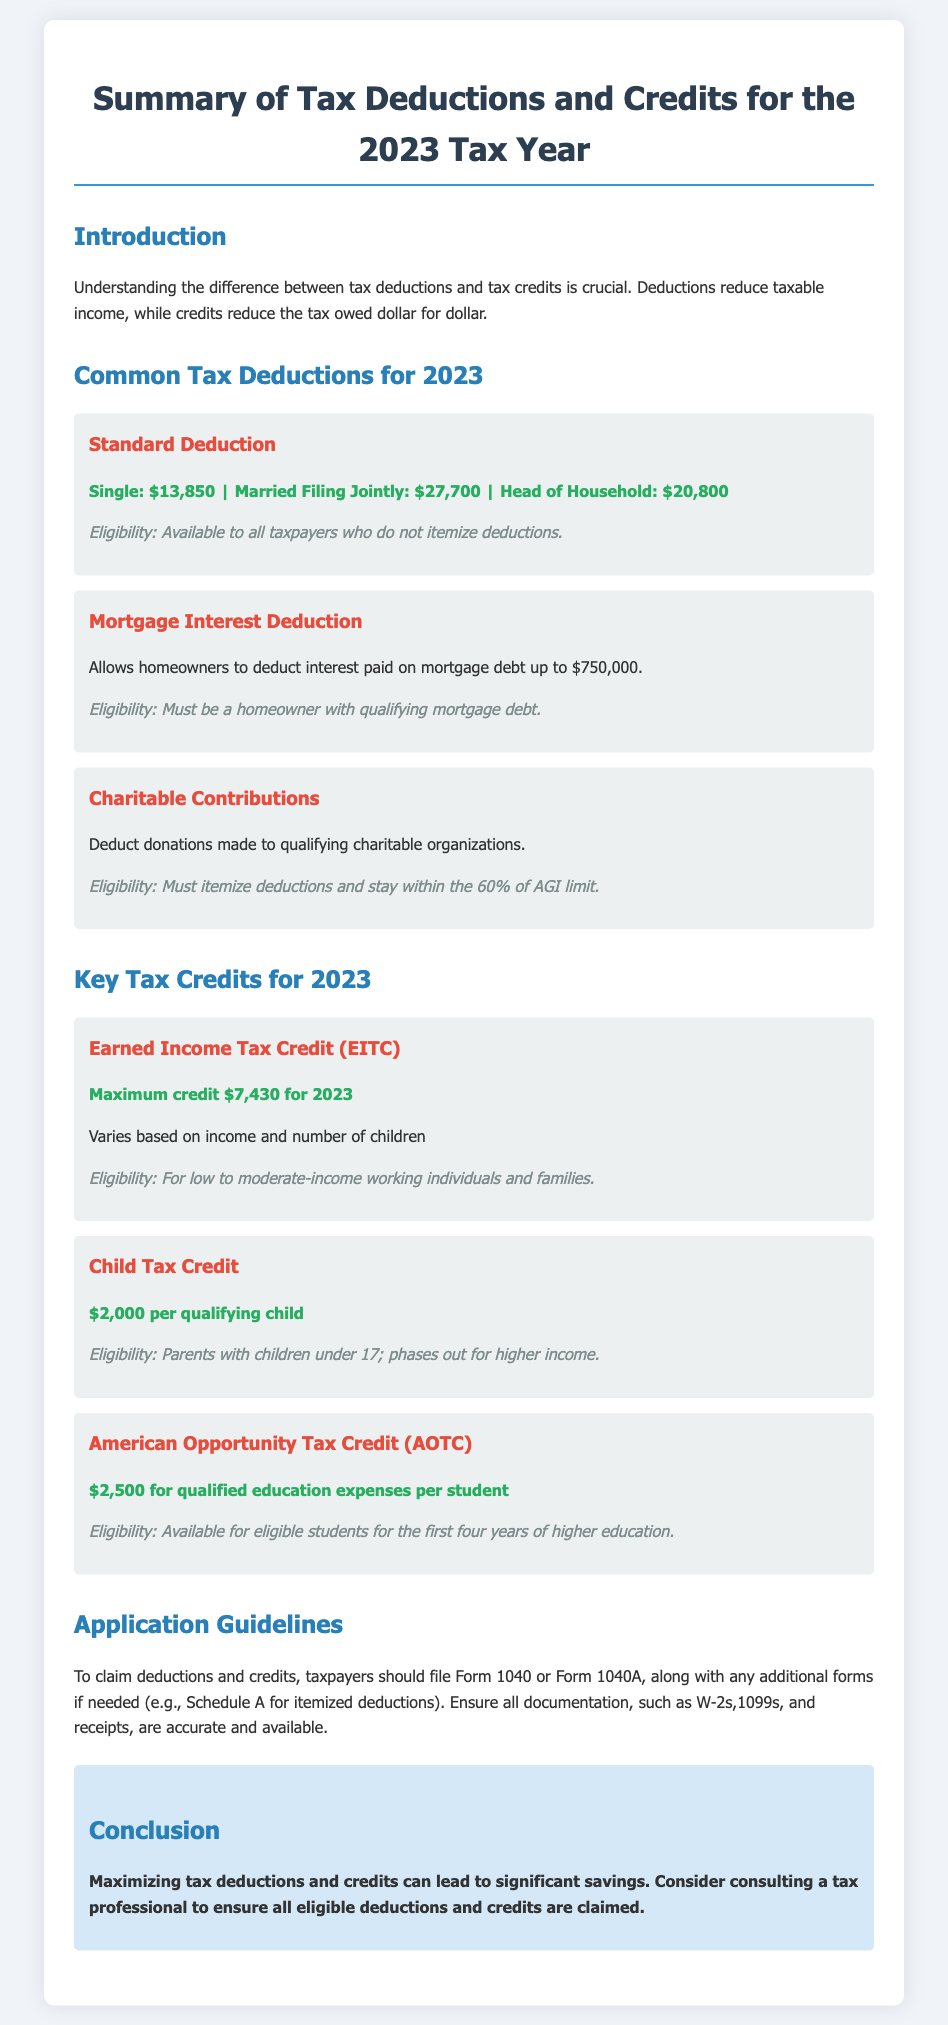What is the amount for the Single Standard Deduction? The Single Standard Deduction is specified in the document as $13,850.
Answer: $13,850 What is the maximum credit for the Earned Income Tax Credit (EITC)? The document states that the maximum credit for EITC in 2023 is $7,430.
Answer: $7,430 What is the eligibility for the Mortgage Interest Deduction? The eligibility criteria for this deduction require being a homeowner with qualifying mortgage debt.
Answer: Homeowner with qualifying mortgage debt How much is the Child Tax Credit per qualifying child? According to the document, the Child Tax Credit is $2,000 per qualifying child.
Answer: $2,000 What is the purpose of the Introduction section? The Introduction section explains the difference between tax deductions and tax credits.
Answer: Difference between tax deductions and tax credits What are taxpayers required to file to claim deductions and credits? Taxpayers need to file Form 1040 or Form 1040A to claim deductions and credits.
Answer: Form 1040 or Form 1040A What is the limit for charitable contributions when itemizing deductions? The document mentions staying within the 60% of AGI limit for charitable contributions when itemizing.
Answer: 60% of AGI limit Which credit is specifically for qualified education expenses? The document clearly states that the American Opportunity Tax Credit (AOTC) is for qualified education expenses.
Answer: American Opportunity Tax Credit (AOTC) 